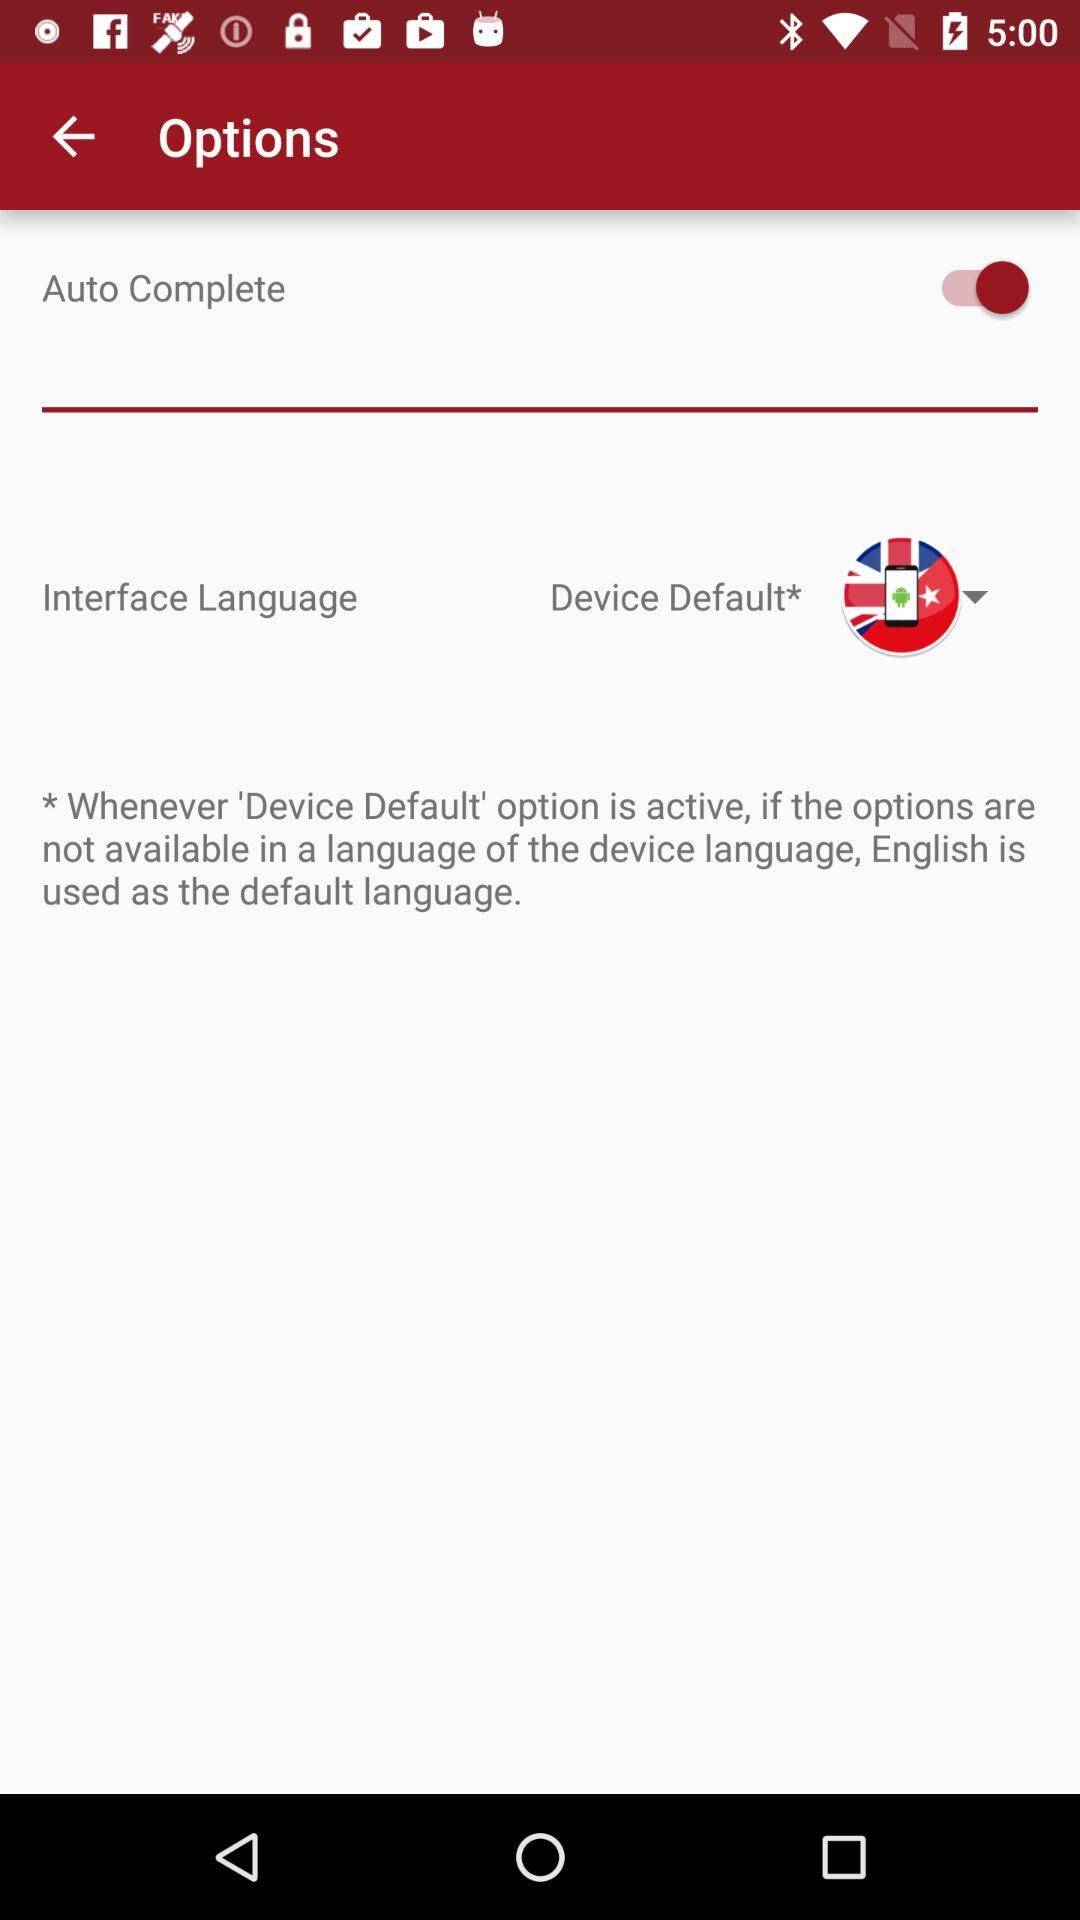Is "Auto Complete" mode on or off? "Auto Complete" mode is "on". 